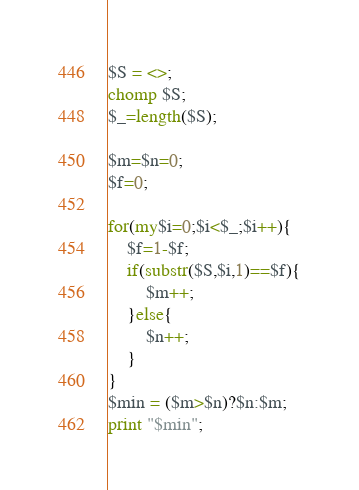<code> <loc_0><loc_0><loc_500><loc_500><_Perl_>$S = <>;
chomp $S;
$_=length($S);

$m=$n=0;
$f=0;

for(my$i=0;$i<$_;$i++){
    $f=1-$f;
    if(substr($S,$i,1)==$f){
        $m++;
    }else{
        $n++;
    }
}
$min = ($m>$n)?$n:$m;
print "$min";
</code> 